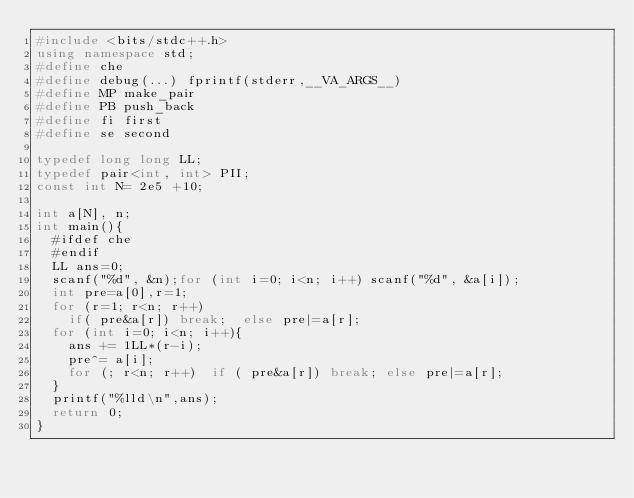<code> <loc_0><loc_0><loc_500><loc_500><_C++_>#include <bits/stdc++.h>
using namespace std;
#define che
#define debug(...) fprintf(stderr,__VA_ARGS__)
#define MP make_pair
#define PB push_back
#define fi first
#define se second

typedef long long LL;
typedef pair<int, int> PII;
const int N= 2e5 +10;

int a[N], n;
int main(){
	#ifdef che
	#endif
	LL ans=0;
	scanf("%d", &n);for (int i=0; i<n; i++) scanf("%d", &a[i]);
	int pre=a[0],r=1;
	for (r=1; r<n; r++)
		if( pre&a[r]) break;	else pre|=a[r];
	for (int i=0; i<n; i++){
		ans += 1LL*(r-i);
		pre^= a[i];
		for (; r<n; r++)	if ( pre&a[r]) break; else pre|=a[r];
	}
	printf("%lld\n",ans);
	return 0;
}</code> 